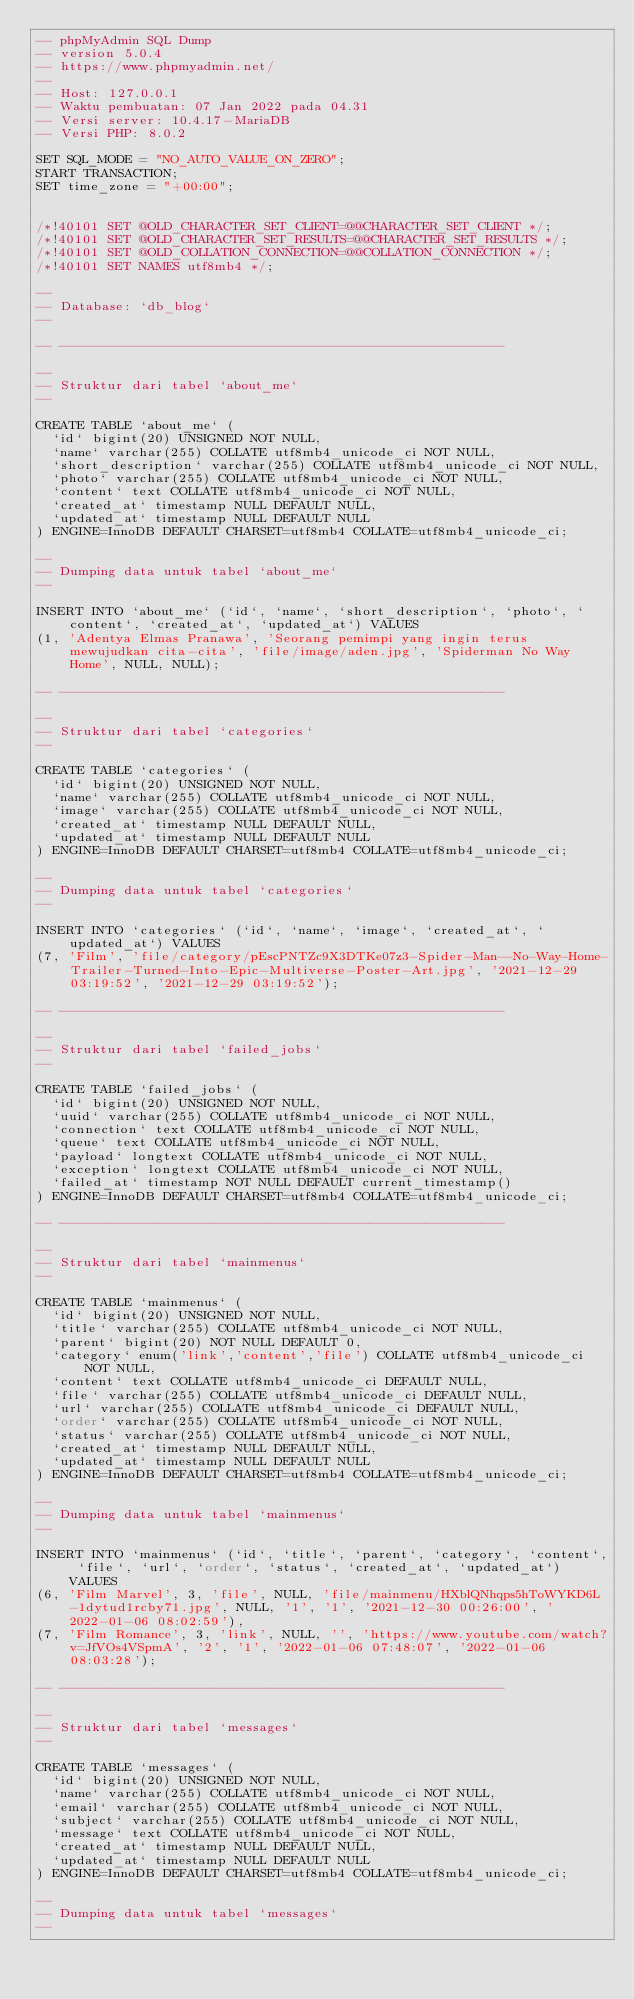Convert code to text. <code><loc_0><loc_0><loc_500><loc_500><_SQL_>-- phpMyAdmin SQL Dump
-- version 5.0.4
-- https://www.phpmyadmin.net/
--
-- Host: 127.0.0.1
-- Waktu pembuatan: 07 Jan 2022 pada 04.31
-- Versi server: 10.4.17-MariaDB
-- Versi PHP: 8.0.2

SET SQL_MODE = "NO_AUTO_VALUE_ON_ZERO";
START TRANSACTION;
SET time_zone = "+00:00";


/*!40101 SET @OLD_CHARACTER_SET_CLIENT=@@CHARACTER_SET_CLIENT */;
/*!40101 SET @OLD_CHARACTER_SET_RESULTS=@@CHARACTER_SET_RESULTS */;
/*!40101 SET @OLD_COLLATION_CONNECTION=@@COLLATION_CONNECTION */;
/*!40101 SET NAMES utf8mb4 */;

--
-- Database: `db_blog`
--

-- --------------------------------------------------------

--
-- Struktur dari tabel `about_me`
--

CREATE TABLE `about_me` (
  `id` bigint(20) UNSIGNED NOT NULL,
  `name` varchar(255) COLLATE utf8mb4_unicode_ci NOT NULL,
  `short_description` varchar(255) COLLATE utf8mb4_unicode_ci NOT NULL,
  `photo` varchar(255) COLLATE utf8mb4_unicode_ci NOT NULL,
  `content` text COLLATE utf8mb4_unicode_ci NOT NULL,
  `created_at` timestamp NULL DEFAULT NULL,
  `updated_at` timestamp NULL DEFAULT NULL
) ENGINE=InnoDB DEFAULT CHARSET=utf8mb4 COLLATE=utf8mb4_unicode_ci;

--
-- Dumping data untuk tabel `about_me`
--

INSERT INTO `about_me` (`id`, `name`, `short_description`, `photo`, `content`, `created_at`, `updated_at`) VALUES
(1, 'Adentya Elmas Pranawa', 'Seorang pemimpi yang ingin terus mewujudkan cita-cita', 'file/image/aden.jpg', 'Spiderman No Way Home', NULL, NULL);

-- --------------------------------------------------------

--
-- Struktur dari tabel `categories`
--

CREATE TABLE `categories` (
  `id` bigint(20) UNSIGNED NOT NULL,
  `name` varchar(255) COLLATE utf8mb4_unicode_ci NOT NULL,
  `image` varchar(255) COLLATE utf8mb4_unicode_ci NOT NULL,
  `created_at` timestamp NULL DEFAULT NULL,
  `updated_at` timestamp NULL DEFAULT NULL
) ENGINE=InnoDB DEFAULT CHARSET=utf8mb4 COLLATE=utf8mb4_unicode_ci;

--
-- Dumping data untuk tabel `categories`
--

INSERT INTO `categories` (`id`, `name`, `image`, `created_at`, `updated_at`) VALUES
(7, 'Film', 'file/category/pEscPNTZc9X3DTKe07z3-Spider-Man--No-Way-Home-Trailer-Turned-Into-Epic-Multiverse-Poster-Art.jpg', '2021-12-29 03:19:52', '2021-12-29 03:19:52');

-- --------------------------------------------------------

--
-- Struktur dari tabel `failed_jobs`
--

CREATE TABLE `failed_jobs` (
  `id` bigint(20) UNSIGNED NOT NULL,
  `uuid` varchar(255) COLLATE utf8mb4_unicode_ci NOT NULL,
  `connection` text COLLATE utf8mb4_unicode_ci NOT NULL,
  `queue` text COLLATE utf8mb4_unicode_ci NOT NULL,
  `payload` longtext COLLATE utf8mb4_unicode_ci NOT NULL,
  `exception` longtext COLLATE utf8mb4_unicode_ci NOT NULL,
  `failed_at` timestamp NOT NULL DEFAULT current_timestamp()
) ENGINE=InnoDB DEFAULT CHARSET=utf8mb4 COLLATE=utf8mb4_unicode_ci;

-- --------------------------------------------------------

--
-- Struktur dari tabel `mainmenus`
--

CREATE TABLE `mainmenus` (
  `id` bigint(20) UNSIGNED NOT NULL,
  `title` varchar(255) COLLATE utf8mb4_unicode_ci NOT NULL,
  `parent` bigint(20) NOT NULL DEFAULT 0,
  `category` enum('link','content','file') COLLATE utf8mb4_unicode_ci NOT NULL,
  `content` text COLLATE utf8mb4_unicode_ci DEFAULT NULL,
  `file` varchar(255) COLLATE utf8mb4_unicode_ci DEFAULT NULL,
  `url` varchar(255) COLLATE utf8mb4_unicode_ci DEFAULT NULL,
  `order` varchar(255) COLLATE utf8mb4_unicode_ci NOT NULL,
  `status` varchar(255) COLLATE utf8mb4_unicode_ci NOT NULL,
  `created_at` timestamp NULL DEFAULT NULL,
  `updated_at` timestamp NULL DEFAULT NULL
) ENGINE=InnoDB DEFAULT CHARSET=utf8mb4 COLLATE=utf8mb4_unicode_ci;

--
-- Dumping data untuk tabel `mainmenus`
--

INSERT INTO `mainmenus` (`id`, `title`, `parent`, `category`, `content`, `file`, `url`, `order`, `status`, `created_at`, `updated_at`) VALUES
(6, 'Film Marvel', 3, 'file', NULL, 'file/mainmenu/HXblQNhqps5hToWYKD6L-1dytud1rcby71.jpg', NULL, '1', '1', '2021-12-30 00:26:00', '2022-01-06 08:02:59'),
(7, 'Film Romance', 3, 'link', NULL, '', 'https://www.youtube.com/watch?v=JfVOs4VSpmA', '2', '1', '2022-01-06 07:48:07', '2022-01-06 08:03:28');

-- --------------------------------------------------------

--
-- Struktur dari tabel `messages`
--

CREATE TABLE `messages` (
  `id` bigint(20) UNSIGNED NOT NULL,
  `name` varchar(255) COLLATE utf8mb4_unicode_ci NOT NULL,
  `email` varchar(255) COLLATE utf8mb4_unicode_ci NOT NULL,
  `subject` varchar(255) COLLATE utf8mb4_unicode_ci NOT NULL,
  `message` text COLLATE utf8mb4_unicode_ci NOT NULL,
  `created_at` timestamp NULL DEFAULT NULL,
  `updated_at` timestamp NULL DEFAULT NULL
) ENGINE=InnoDB DEFAULT CHARSET=utf8mb4 COLLATE=utf8mb4_unicode_ci;

--
-- Dumping data untuk tabel `messages`
--
</code> 